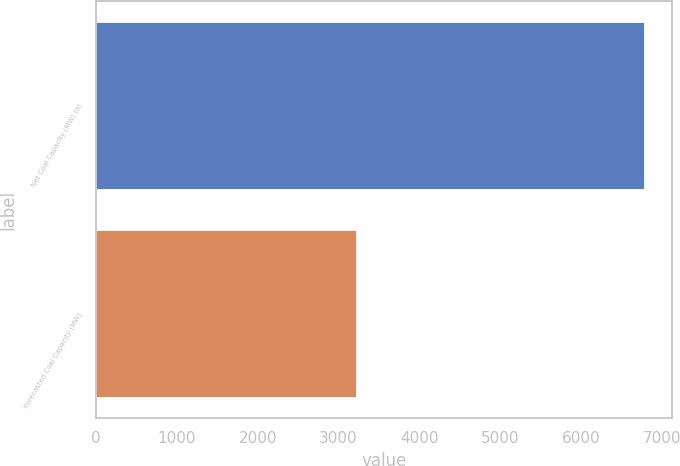Convert chart to OTSL. <chart><loc_0><loc_0><loc_500><loc_500><bar_chart><fcel>Net Coal Capacity (MW) (a)<fcel>Forecasted Coal Capacity (MW)<nl><fcel>6787<fcel>3215<nl></chart> 